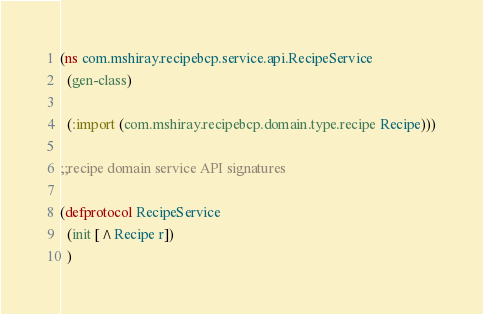<code> <loc_0><loc_0><loc_500><loc_500><_Clojure_>(ns com.mshiray.recipebcp.service.api.RecipeService
  (gen-class)

  (:import (com.mshiray.recipebcp.domain.type.recipe Recipe)))

;;recipe domain service API signatures

(defprotocol RecipeService
  (init [^Recipe r])
  )</code> 